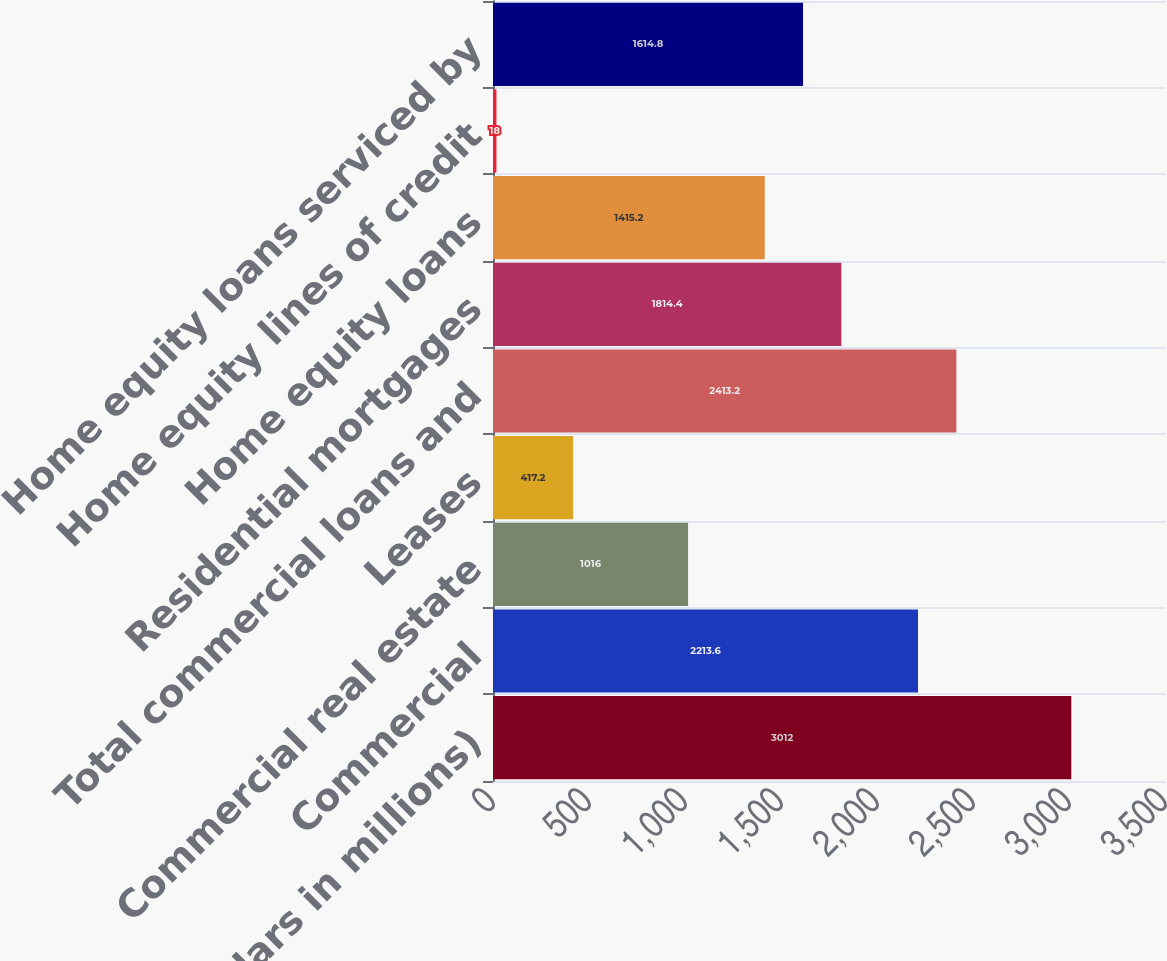Convert chart. <chart><loc_0><loc_0><loc_500><loc_500><bar_chart><fcel>(dollars in millions)<fcel>Commercial<fcel>Commercial real estate<fcel>Leases<fcel>Total commercial loans and<fcel>Residential mortgages<fcel>Home equity loans<fcel>Home equity lines of credit<fcel>Home equity loans serviced by<nl><fcel>3012<fcel>2213.6<fcel>1016<fcel>417.2<fcel>2413.2<fcel>1814.4<fcel>1415.2<fcel>18<fcel>1614.8<nl></chart> 